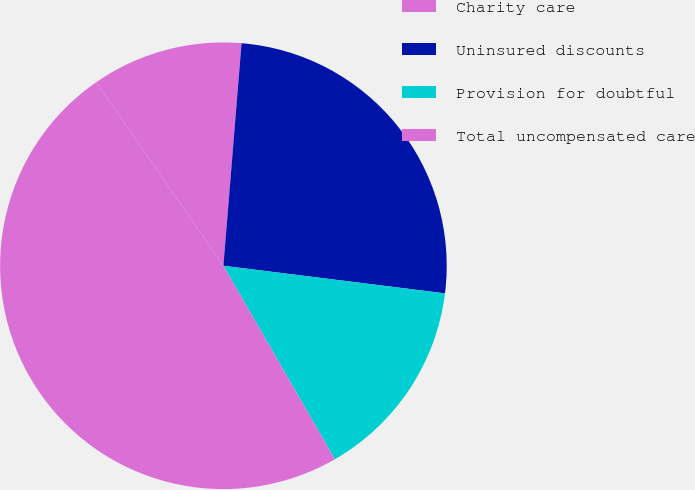Convert chart. <chart><loc_0><loc_0><loc_500><loc_500><pie_chart><fcel>Charity care<fcel>Uninsured discounts<fcel>Provision for doubtful<fcel>Total uncompensated care<nl><fcel>10.94%<fcel>25.68%<fcel>14.71%<fcel>48.68%<nl></chart> 